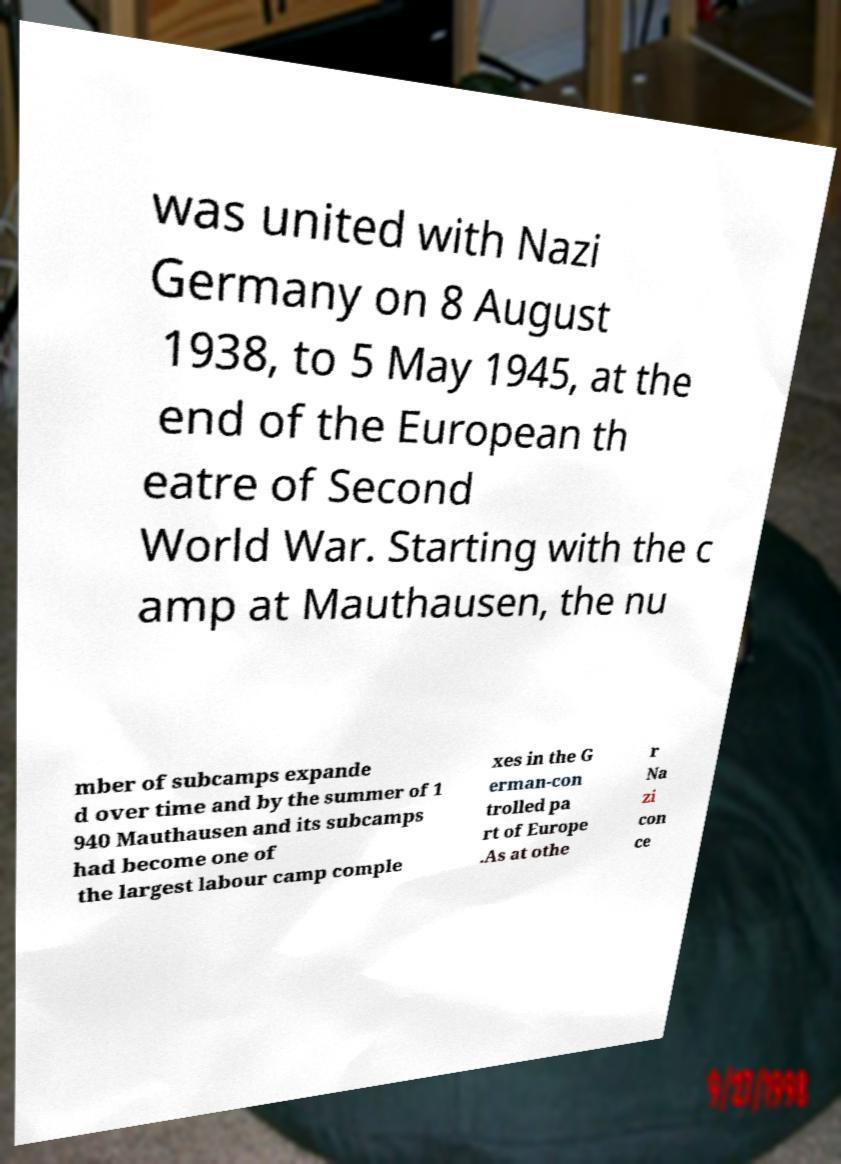Can you accurately transcribe the text from the provided image for me? was united with Nazi Germany on 8 August 1938, to 5 May 1945, at the end of the European th eatre of Second World War. Starting with the c amp at Mauthausen, the nu mber of subcamps expande d over time and by the summer of 1 940 Mauthausen and its subcamps had become one of the largest labour camp comple xes in the G erman-con trolled pa rt of Europe .As at othe r Na zi con ce 